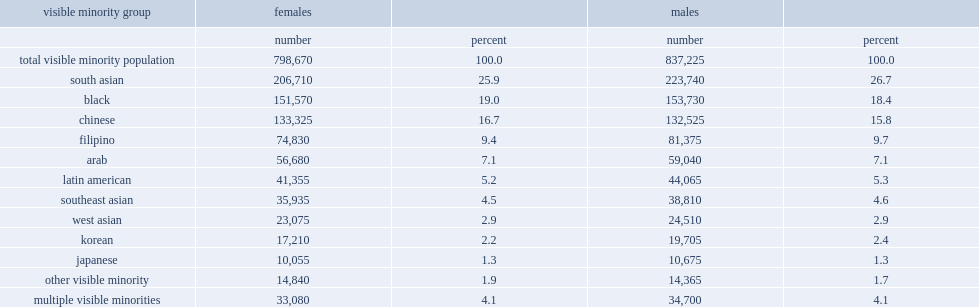What is the largest three visible minority groups? South asian black chinese. What is the percentage of minority girls are south asian? 25.9. What is the percentage of minority girls are chinese? 16.7. 